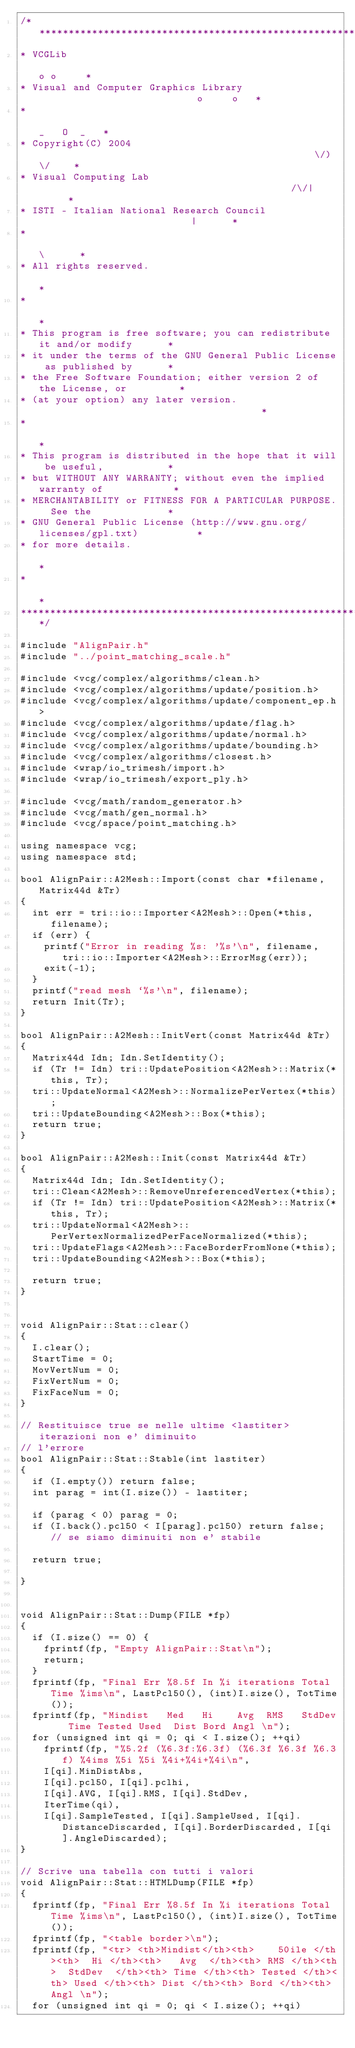<code> <loc_0><loc_0><loc_500><loc_500><_C++_>/****************************************************************************
* VCGLib                                                            o o     *
* Visual and Computer Graphics Library                            o     o   *
*                                                                _   O  _   *
* Copyright(C) 2004                                                \/)\/    *
* Visual Computing Lab                                            /\/|      *
* ISTI - Italian National Research Council                           |      *
*                                                                    \      *
* All rights reserved.                                                      *
*                                                                           *
* This program is free software; you can redistribute it and/or modify      *
* it under the terms of the GNU General Public License as published by      *
* the Free Software Foundation; either version 2 of the License, or         *
* (at your option) any later version.                                       *
*                                                                           *
* This program is distributed in the hope that it will be useful,           *
* but WITHOUT ANY WARRANTY; without even the implied warranty of            *
* MERCHANTABILITY or FITNESS FOR A PARTICULAR PURPOSE.  See the             *
* GNU General Public License (http://www.gnu.org/licenses/gpl.txt)          *
* for more details.                                                         *
*                                                                           *
****************************************************************************/

#include "AlignPair.h"
#include "../point_matching_scale.h"

#include <vcg/complex/algorithms/clean.h>
#include <vcg/complex/algorithms/update/position.h>
#include <vcg/complex/algorithms/update/component_ep.h>
#include <vcg/complex/algorithms/update/flag.h>
#include <vcg/complex/algorithms/update/normal.h>
#include <vcg/complex/algorithms/update/bounding.h>
#include <vcg/complex/algorithms/closest.h>
#include <wrap/io_trimesh/import.h>
#include <wrap/io_trimesh/export_ply.h>

#include <vcg/math/random_generator.h>
#include <vcg/math/gen_normal.h>
#include <vcg/space/point_matching.h>

using namespace vcg;
using namespace std;

bool AlignPair::A2Mesh::Import(const char *filename, Matrix44d &Tr)
{
  int err = tri::io::Importer<A2Mesh>::Open(*this, filename);
  if (err) {
    printf("Error in reading %s: '%s'\n", filename, tri::io::Importer<A2Mesh>::ErrorMsg(err));
    exit(-1);
  }
  printf("read mesh `%s'\n", filename);
  return Init(Tr);
}

bool AlignPair::A2Mesh::InitVert(const Matrix44d &Tr)
{
  Matrix44d Idn; Idn.SetIdentity();
  if (Tr != Idn) tri::UpdatePosition<A2Mesh>::Matrix(*this, Tr);
  tri::UpdateNormal<A2Mesh>::NormalizePerVertex(*this);
  tri::UpdateBounding<A2Mesh>::Box(*this);
  return true;
}

bool AlignPair::A2Mesh::Init(const Matrix44d &Tr)
{
  Matrix44d Idn; Idn.SetIdentity();
  tri::Clean<A2Mesh>::RemoveUnreferencedVertex(*this);
  if (Tr != Idn) tri::UpdatePosition<A2Mesh>::Matrix(*this, Tr);
  tri::UpdateNormal<A2Mesh>::PerVertexNormalizedPerFaceNormalized(*this);
  tri::UpdateFlags<A2Mesh>::FaceBorderFromNone(*this);
  tri::UpdateBounding<A2Mesh>::Box(*this);

  return true;
}


void AlignPair::Stat::clear()
{
  I.clear();
  StartTime = 0;
  MovVertNum = 0;
  FixVertNum = 0;
  FixFaceNum = 0;
}

// Restituisce true se nelle ultime <lastiter> iterazioni non e' diminuito
// l'errore
bool AlignPair::Stat::Stable(int lastiter)
{
  if (I.empty()) return false;
  int parag = int(I.size()) - lastiter;

  if (parag < 0) parag = 0;
  if (I.back().pcl50 < I[parag].pcl50) return false; // se siamo diminuiti non e' stabile

  return true;

}


void AlignPair::Stat::Dump(FILE *fp)
{
  if (I.size() == 0) {
    fprintf(fp, "Empty AlignPair::Stat\n");
    return;
  }
  fprintf(fp, "Final Err %8.5f In %i iterations Total Time %ims\n", LastPcl50(), (int)I.size(), TotTime());
  fprintf(fp, "Mindist   Med   Hi    Avg  RMS   StdDev   Time Tested Used  Dist Bord Angl \n");
  for (unsigned int qi = 0; qi < I.size(); ++qi)
    fprintf(fp, "%5.2f (%6.3f:%6.3f) (%6.3f %6.3f %6.3f) %4ims %5i %5i %4i+%4i+%4i\n",
    I[qi].MinDistAbs,
    I[qi].pcl50, I[qi].pclhi,
    I[qi].AVG, I[qi].RMS, I[qi].StdDev,
    IterTime(qi),
    I[qi].SampleTested, I[qi].SampleUsed, I[qi].DistanceDiscarded, I[qi].BorderDiscarded, I[qi].AngleDiscarded);
}

// Scrive una tabella con tutti i valori
void AlignPair::Stat::HTMLDump(FILE *fp)
{
  fprintf(fp, "Final Err %8.5f In %i iterations Total Time %ims\n", LastPcl50(), (int)I.size(), TotTime());
  fprintf(fp, "<table border>\n");
  fprintf(fp, "<tr> <th>Mindist</th><th>    50ile </th><th>  Hi </th><th>   Avg  </th><th> RMS </th><th>  StdDev  </th><th> Time </th><th> Tested </th><th> Used </th><th> Dist </th><th> Bord </th><th> Angl \n");
  for (unsigned int qi = 0; qi < I.size(); ++qi)</code> 